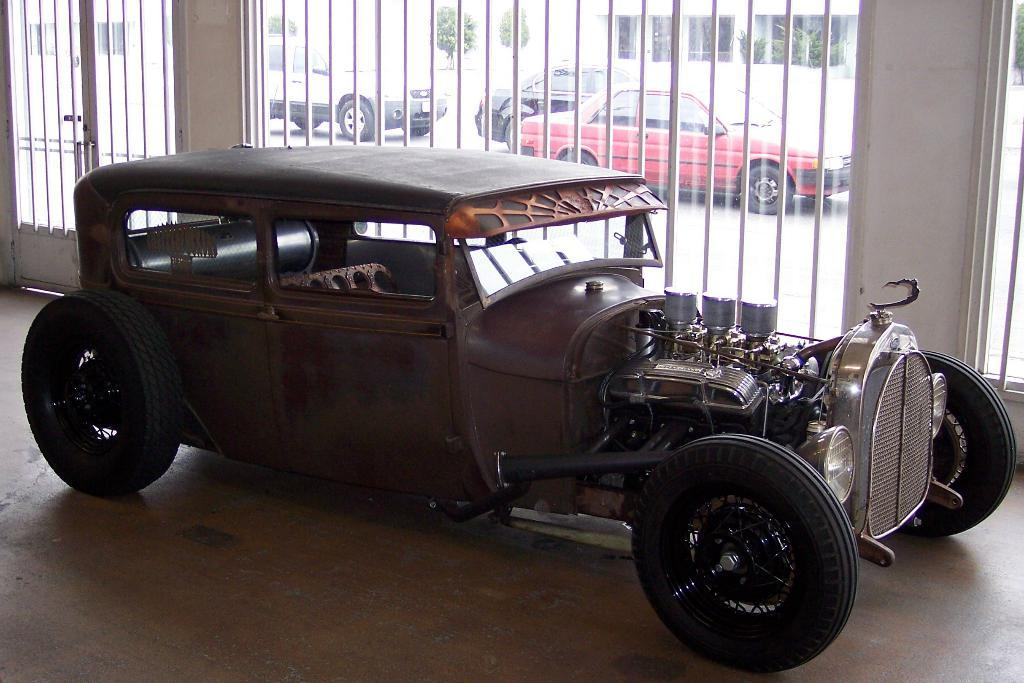What types of objects are present in the image? There are vehicles in the image. Can you describe one of the vehicles in more detail? One of the vehicles is brown in color. What can be seen in the background of the image? There is a gate and plants visible in the background of the image. How many balloons are tied to the truck in the image? There is no truck or balloons present in the image. What type of harbor can be seen in the background of the image? There is no harbor visible in the image; it features vehicles, a gate, and plants in the background. 